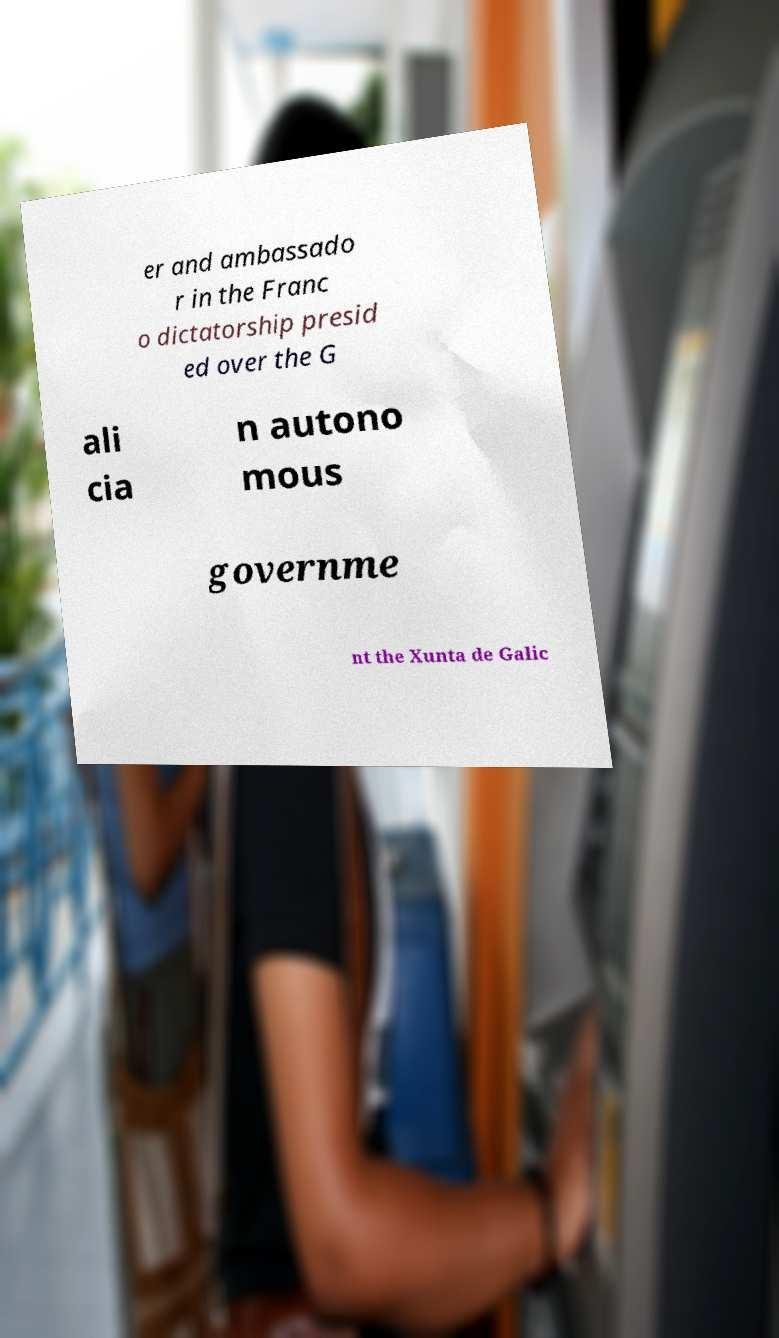Please identify and transcribe the text found in this image. er and ambassado r in the Franc o dictatorship presid ed over the G ali cia n autono mous governme nt the Xunta de Galic 